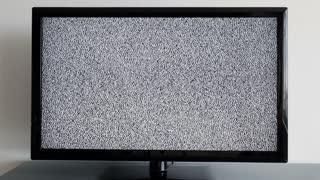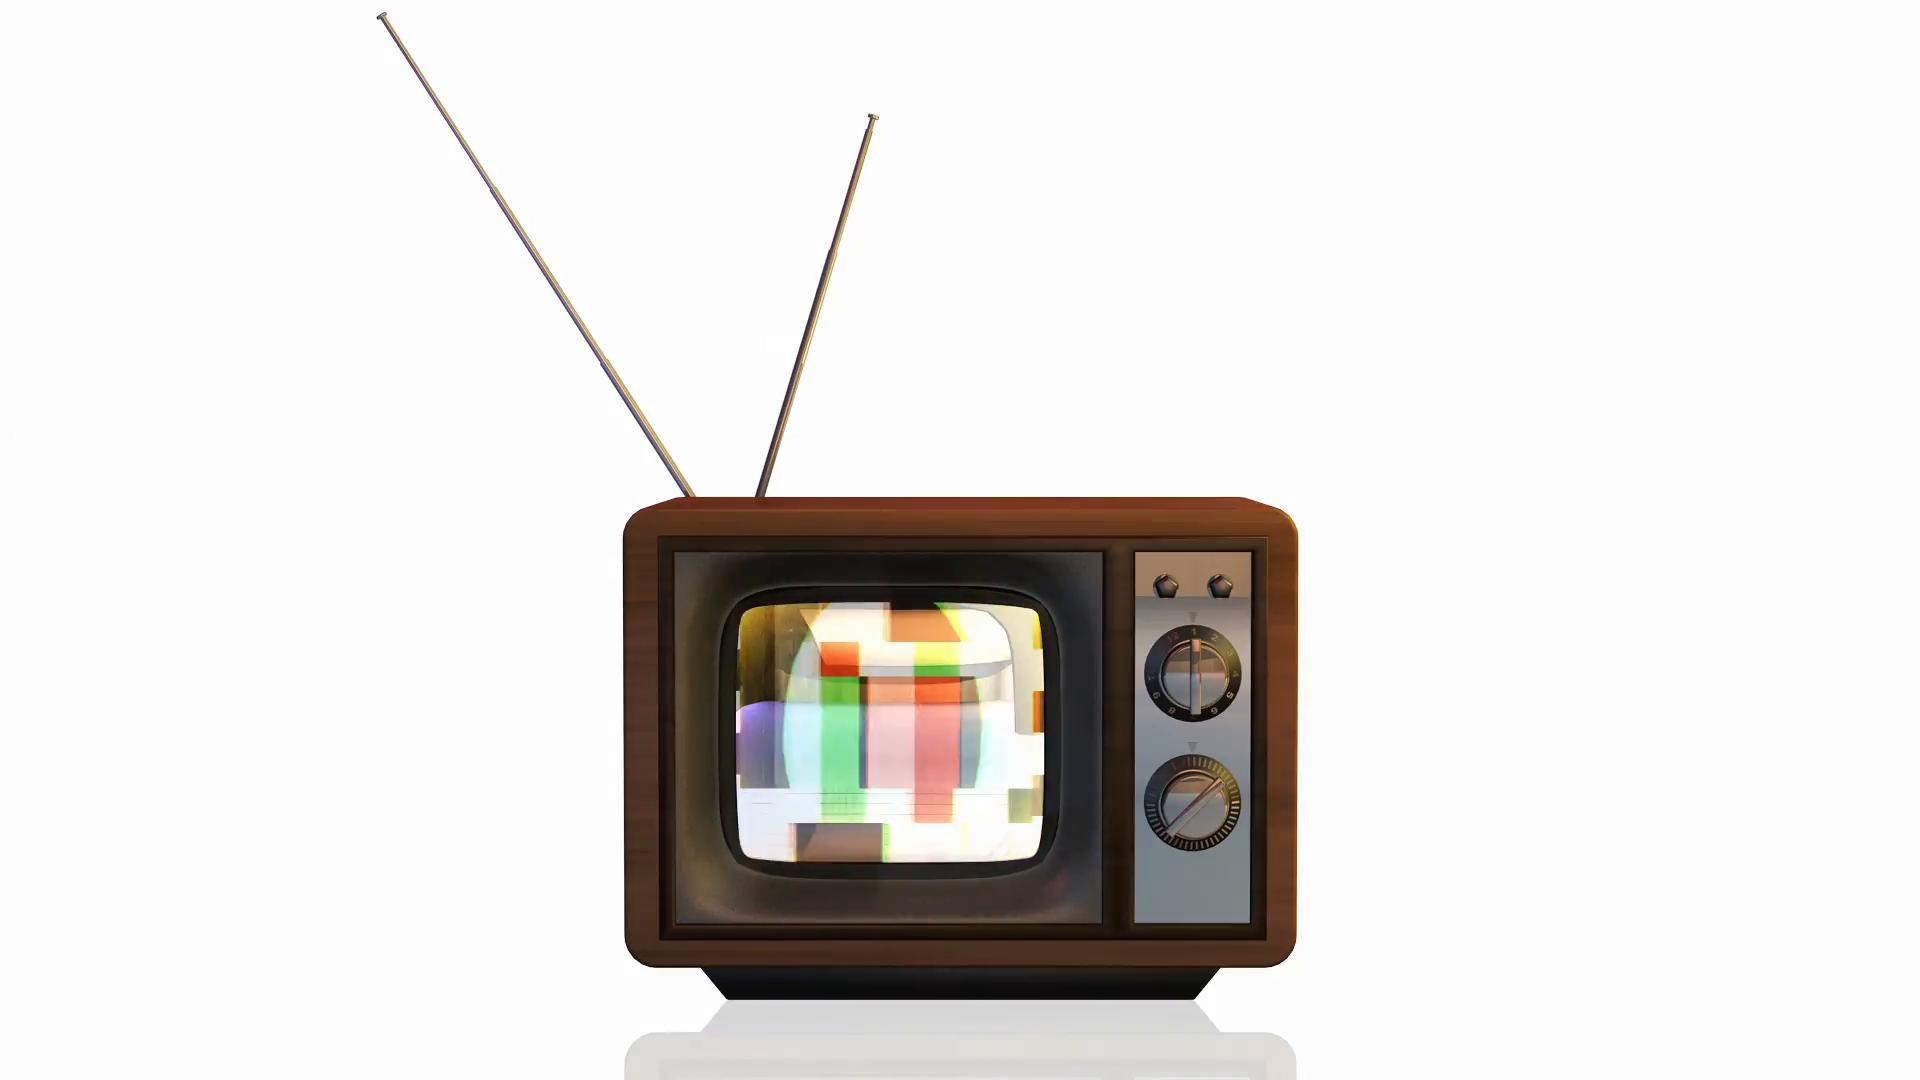The first image is the image on the left, the second image is the image on the right. For the images displayed, is the sentence "One of the television sets includes a color image." factually correct? Answer yes or no. Yes. The first image is the image on the left, the second image is the image on the right. Examine the images to the left and right. Is the description "Each image shows one old-fashioned TV set with grainy static """"fuzz"""" on the screen, and the right image shows a TV set on a solid-colored background." accurate? Answer yes or no. No. 